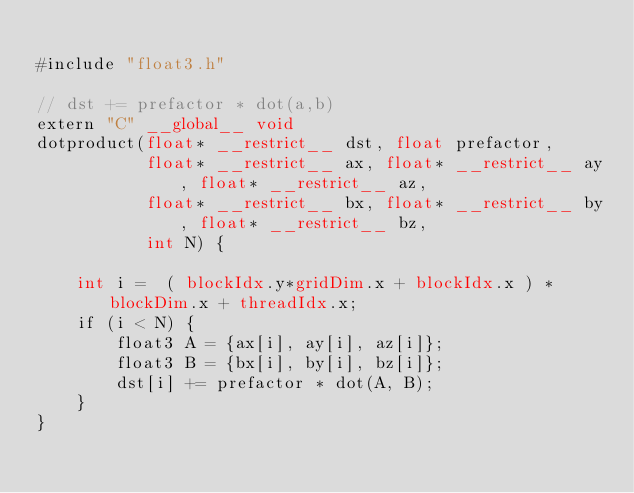<code> <loc_0><loc_0><loc_500><loc_500><_Cuda_>
#include "float3.h"

// dst += prefactor * dot(a,b)
extern "C" __global__ void
dotproduct(float* __restrict__ dst, float prefactor,
           float* __restrict__ ax, float* __restrict__ ay, float* __restrict__ az,
           float* __restrict__ bx, float* __restrict__ by, float* __restrict__ bz,
           int N) {

	int i =  ( blockIdx.y*gridDim.x + blockIdx.x ) * blockDim.x + threadIdx.x;
	if (i < N) {
		float3 A = {ax[i], ay[i], az[i]};
		float3 B = {bx[i], by[i], bz[i]};
		dst[i] += prefactor * dot(A, B);
	}
}

</code> 